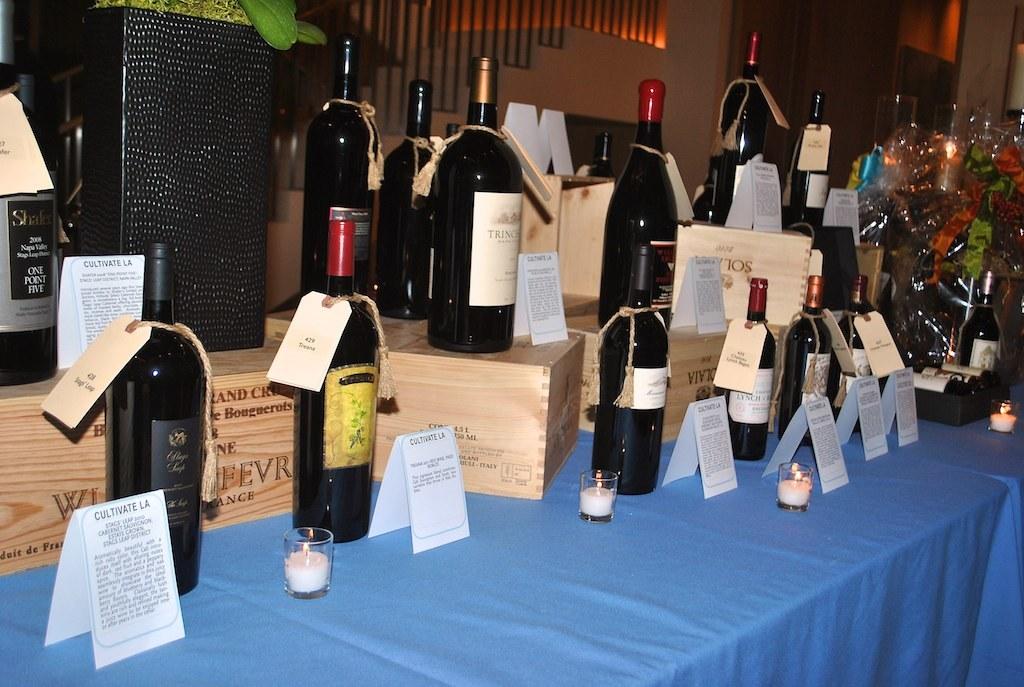Is this from cultivate la?
Make the answer very short. Yes. 